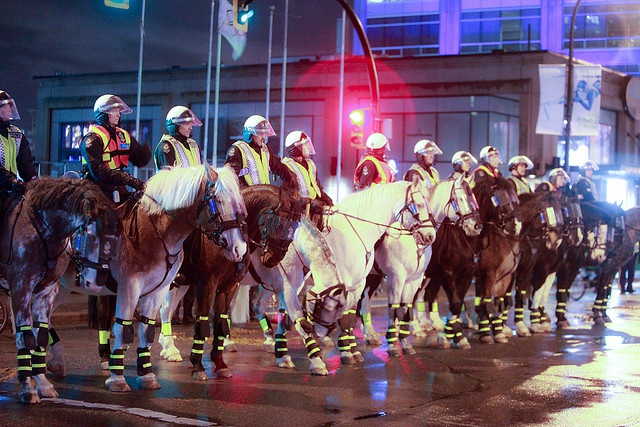Describe the objects in this image and their specific colors. I can see horse in black, maroon, beige, and purple tones, horse in black, maroon, purple, and navy tones, horse in black, maroon, brown, and purple tones, horse in black, beige, maroon, and brown tones, and horse in black, darkgray, beige, and brown tones in this image. 